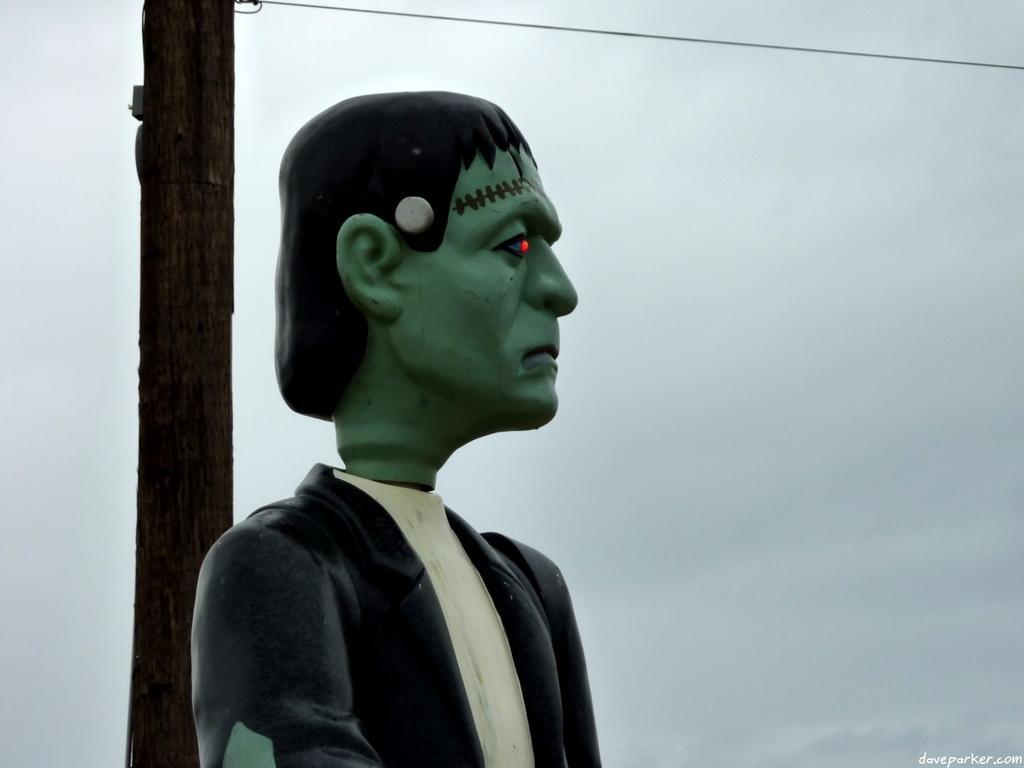Please provide a concise description of this image. In this image we can see a sculpture of a man and sky with clouds in the background. 